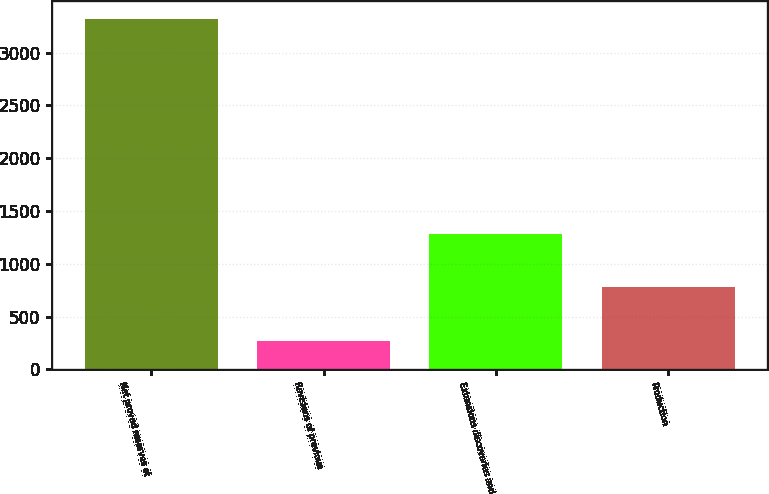Convert chart to OTSL. <chart><loc_0><loc_0><loc_500><loc_500><bar_chart><fcel>Net proved reserves at<fcel>Revisions of previous<fcel>Extensions discoveries and<fcel>Production<nl><fcel>3317.9<fcel>270.6<fcel>1285<fcel>777.8<nl></chart> 